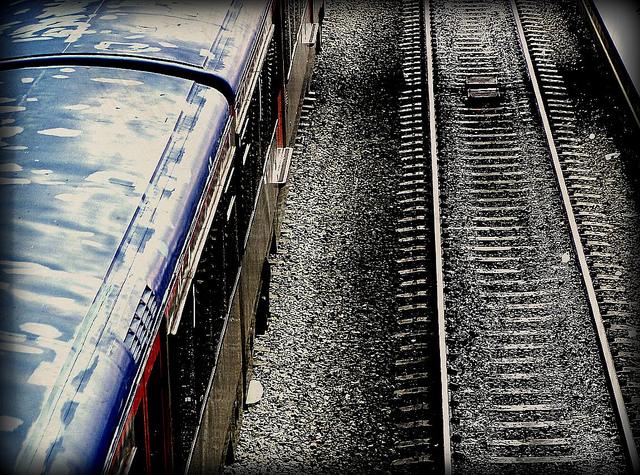What is this used for?
Quick response, please. Trains. In what condition is the roof of the train car?
Quick response, please. Bad. What is the color of the roof the train?
Short answer required. Blue. 